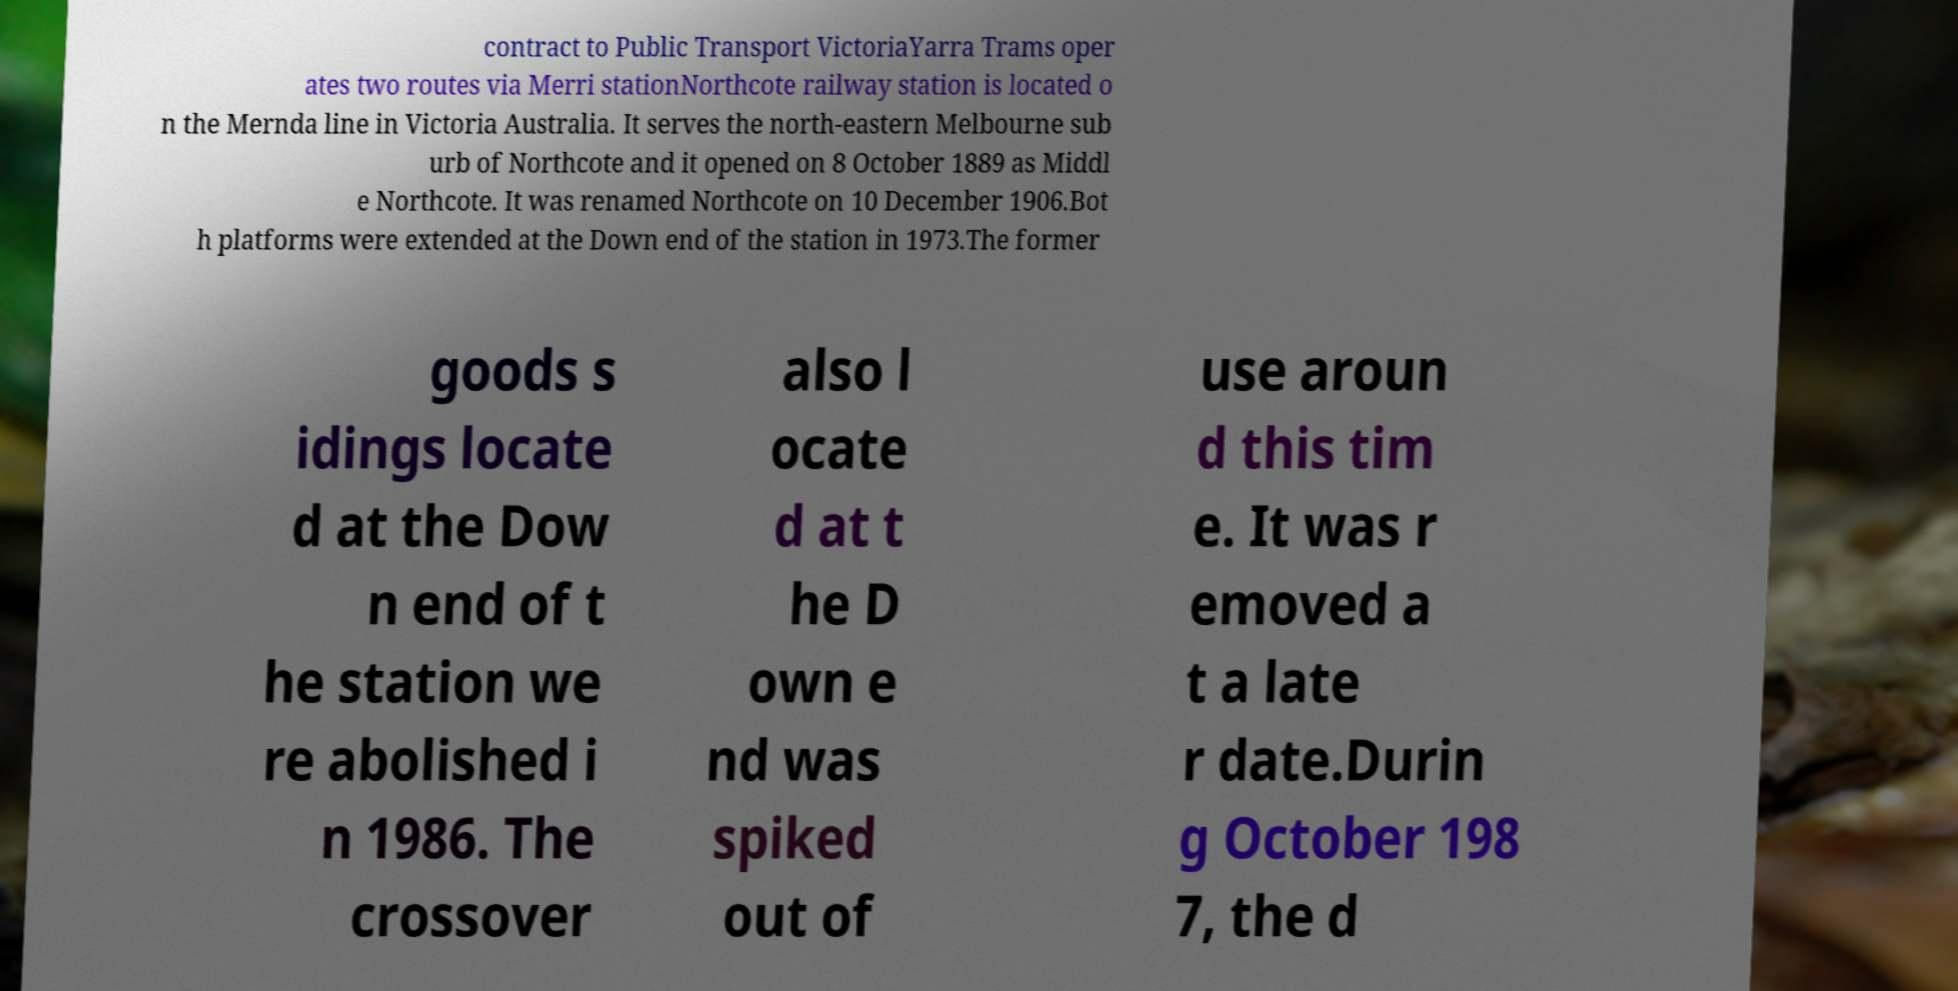What messages or text are displayed in this image? I need them in a readable, typed format. contract to Public Transport VictoriaYarra Trams oper ates two routes via Merri stationNorthcote railway station is located o n the Mernda line in Victoria Australia. It serves the north-eastern Melbourne sub urb of Northcote and it opened on 8 October 1889 as Middl e Northcote. It was renamed Northcote on 10 December 1906.Bot h platforms were extended at the Down end of the station in 1973.The former goods s idings locate d at the Dow n end of t he station we re abolished i n 1986. The crossover also l ocate d at t he D own e nd was spiked out of use aroun d this tim e. It was r emoved a t a late r date.Durin g October 198 7, the d 